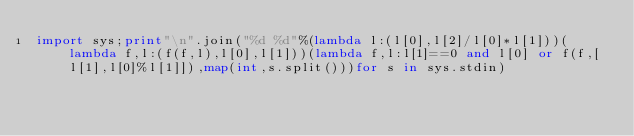<code> <loc_0><loc_0><loc_500><loc_500><_Python_>import sys;print"\n".join("%d %d"%(lambda l:(l[0],l[2]/l[0]*l[1]))(lambda f,l:(f(f,l),l[0],l[1]))(lambda f,l:l[1]==0 and l[0] or f(f,[l[1],l[0]%l[1]]),map(int,s.split()))for s in sys.stdin)</code> 